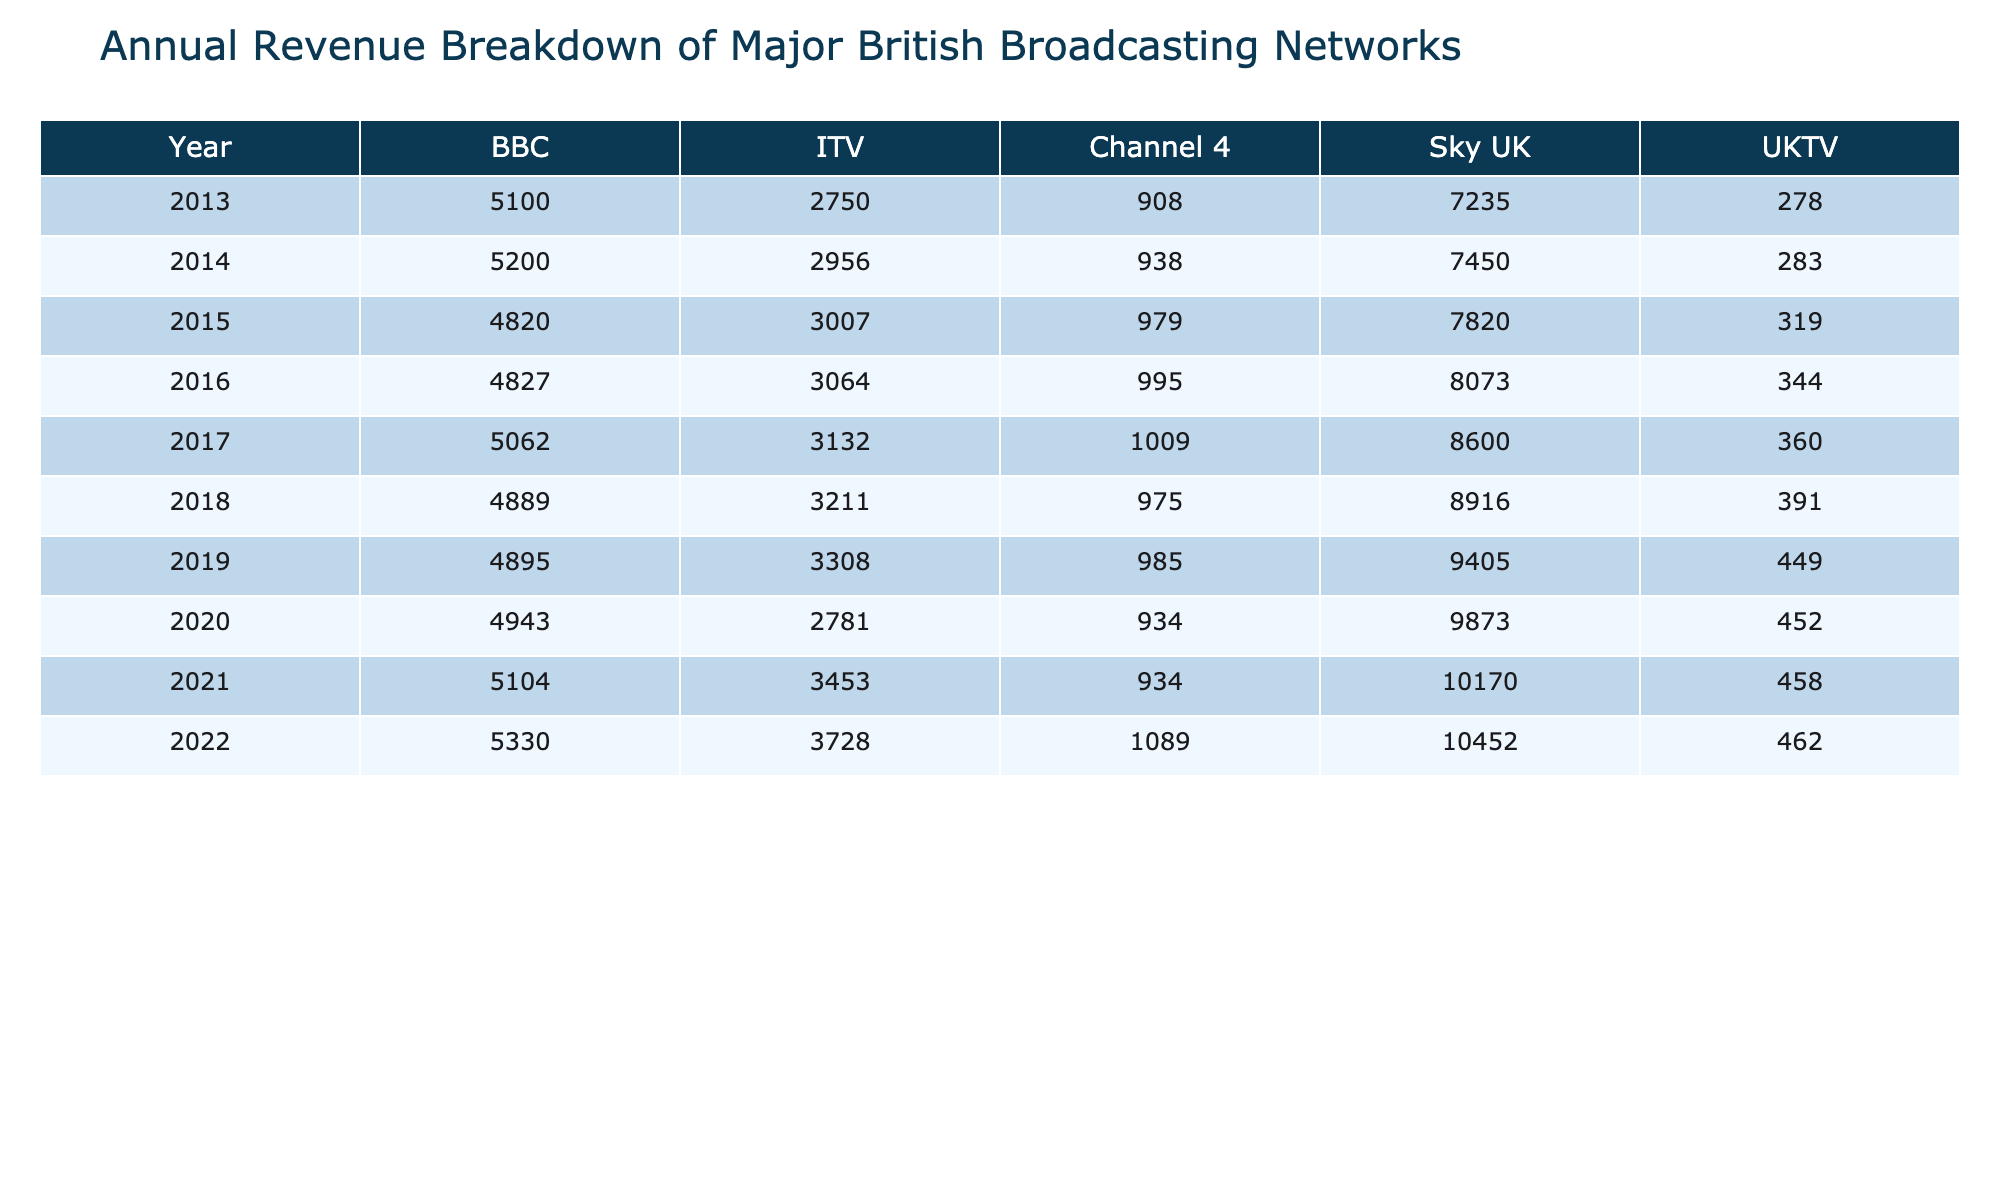What was the annual revenue of ITV in 2020? The table shows that ITV's revenue in 2020 was £2,781 million.
Answer: £2,781 million Which broadcasting network had the highest revenue in 2018? In 2018, Sky UK had the highest revenue of £8,916 million compared to others.
Answer: Sky UK What is the difference in revenue between BBC and Channel 4 in 2021? BBC's revenue in 2021 was £5,104 million and Channel 4's was £934 million. The difference is £5,104 million - £934 million = £4,170 million.
Answer: £4,170 million What was the average revenue of UKTV over the past decade? Adding up UKTV's revenues from 2013 to 2022 gives £278 + £283 + £319 + £344 + £360 + £391 + £449 + £452 + £462 = £3,324 million. Dividing by 10 results in an average of £332.4 million.
Answer: £332.4 million Did Channel 4's revenue increase every year over the past decade? Channel 4's revenues from 2013 (£908 million) to 2022 (£1,089 million) show an overall increase, but there were fluctuations, particularly a drop in 2020. Thus, it did not increase every year.
Answer: No Which channel saw the largest percentage increase in revenue from 2013 to 2022? The revenue for BBC increased from £5,100 million in 2013 to £5,330 million in 2022. This is an increase of ~4.5%. Sky UK saw an increase from £7,235 million to £10,452 million, which is ~44.5%. Therefore, Sky UK saw the largest percentage increase.
Answer: Sky UK What was the total revenue for all networks combined in 2019? The total revenue for 2019 can be calculated as 4895 + 3308 + 985 + 9405 + 449 = 19,042 million.
Answer: £19,042 million Is there a year where BBC's revenue was lower than ITV's? In all the years listed, BBC's revenue was always higher than ITV's revenue. Therefore, there is no year where BBC's revenue was lower.
Answer: No 